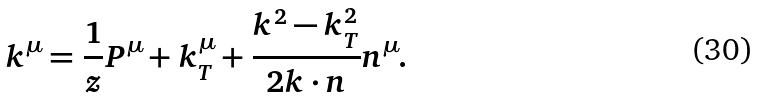Convert formula to latex. <formula><loc_0><loc_0><loc_500><loc_500>k ^ { \mu } = \frac { 1 } { z } P ^ { \mu } + k ^ { \mu } _ { T } + \frac { k ^ { 2 } - k ^ { 2 } _ { T } } { 2 k \cdot n } n ^ { \mu } .</formula> 